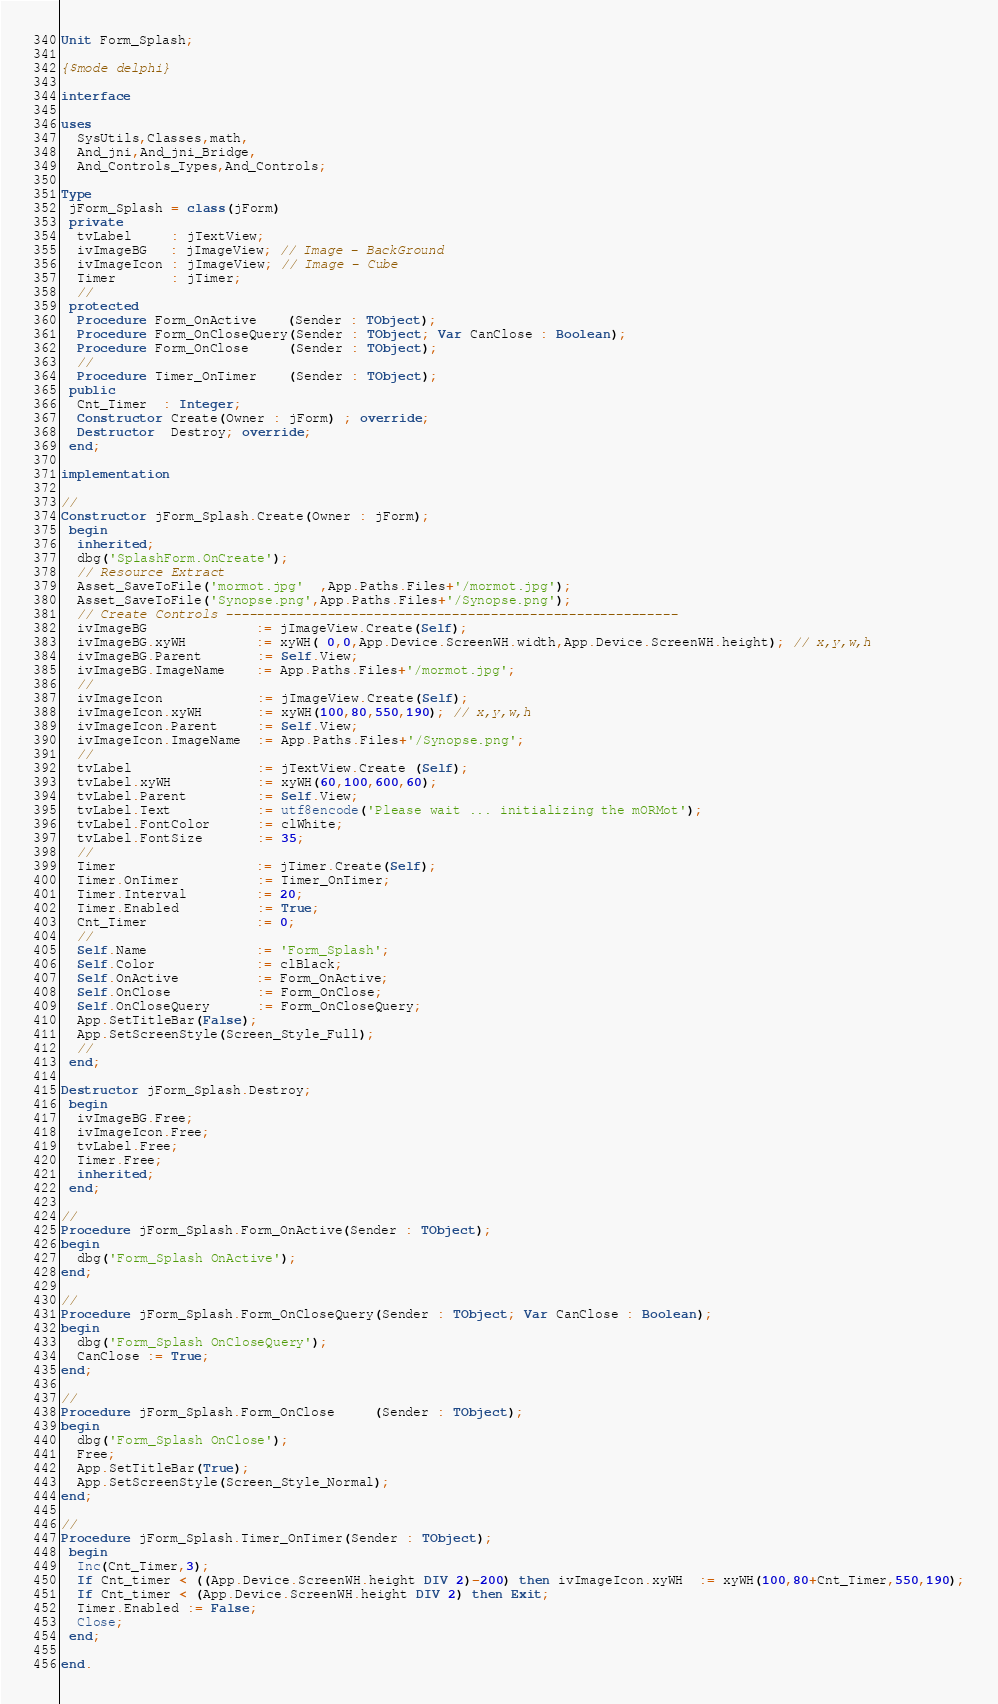Convert code to text. <code><loc_0><loc_0><loc_500><loc_500><_Pascal_>Unit Form_Splash;

{$mode delphi}

interface

uses
  SysUtils,Classes,math,
  And_jni,And_jni_Bridge,
  And_Controls_Types,And_Controls;

Type
 jForm_Splash = class(jForm)
 private
  tvLabel     : jTextView;
  ivImageBG   : jImageView; // Image - BackGround
  ivImageIcon : jImageView; // Image - Cube
  Timer       : jTimer;
  //
 protected 
  Procedure Form_OnActive    (Sender : TObject);
  Procedure Form_OnCloseQuery(Sender : TObject; Var CanClose : Boolean);
  Procedure Form_OnClose     (Sender : TObject);
  //
  Procedure Timer_OnTimer    (Sender : TObject);
 public
  Cnt_Timer  : Integer;
  Constructor Create(Owner : jForm) ; override;
  Destructor  Destroy; override;
 end;

implementation

//
Constructor jForm_Splash.Create(Owner : jForm);
 begin
  inherited;
  dbg('SplashForm.OnCreate');
  // Resource Extract
  Asset_SaveToFile('mormot.jpg'  ,App.Paths.Files+'/mormot.jpg');
  Asset_SaveToFile('Synopse.png',App.Paths.Files+'/Synopse.png');
  // Create Controls ----------------------------------------------------------
  ivImageBG              := jImageView.Create(Self);
  ivImageBG.xyWH         := xyWH( 0,0,App.Device.ScreenWH.width,App.Device.ScreenWH.height); // x,y,w,h
  ivImageBG.Parent       := Self.View;
  ivImageBG.ImageName    := App.Paths.Files+'/mormot.jpg';
  //
  ivImageIcon            := jImageView.Create(Self);
  ivImageIcon.xyWH       := xyWH(100,80,550,190); // x,y,w,h
  ivImageIcon.Parent     := Self.View;
  ivImageIcon.ImageName  := App.Paths.Files+'/Synopse.png';
  //
  tvLabel                := jTextView.Create (Self);
  tvLabel.xyWH           := xyWH(60,100,600,60);
  tvLabel.Parent         := Self.View;
  tvLabel.Text           := utf8encode('Please wait ... initializing the mORMot');
  tvLabel.FontColor      := clWhite;
  tvLabel.FontSize       := 35;
  //
  Timer                  := jTimer.Create(Self);
  Timer.OnTimer          := Timer_OnTimer;
  Timer.Interval         := 20;
  Timer.Enabled          := True;
  Cnt_Timer              := 0;
  //
  Self.Name              := 'Form_Splash';
  Self.Color             := clBlack;
  Self.OnActive          := Form_OnActive;
  Self.OnClose           := Form_OnClose;
  Self.OnCloseQuery      := Form_OnCloseQuery;
  App.SetTitleBar(False);
  App.SetScreenStyle(Screen_Style_Full);
  //
 end;

Destructor jForm_Splash.Destroy;
 begin
  ivImageBG.Free;
  ivImageIcon.Free;
  tvLabel.Free;
  Timer.Free;
  inherited;
 end;

//
Procedure jForm_Splash.Form_OnActive(Sender : TObject);
begin
  dbg('Form_Splash OnActive');
end;

//
Procedure jForm_Splash.Form_OnCloseQuery(Sender : TObject; Var CanClose : Boolean);
begin
  dbg('Form_Splash OnCloseQuery');
  CanClose := True;
end;

//
Procedure jForm_Splash.Form_OnClose     (Sender : TObject);
begin
  dbg('Form_Splash OnClose');
  Free;
  App.SetTitleBar(True);
  App.SetScreenStyle(Screen_Style_Normal);
end;

//
Procedure jForm_Splash.Timer_OnTimer(Sender : TObject);
 begin
  Inc(Cnt_Timer,3);
  If Cnt_timer < ((App.Device.ScreenWH.height DIV 2)-200) then ivImageIcon.xyWH  := xyWH(100,80+Cnt_Timer,550,190);
  If Cnt_timer < (App.Device.ScreenWH.height DIV 2) then Exit;
  Timer.Enabled := False;
  Close;
 end;

end.
</code> 